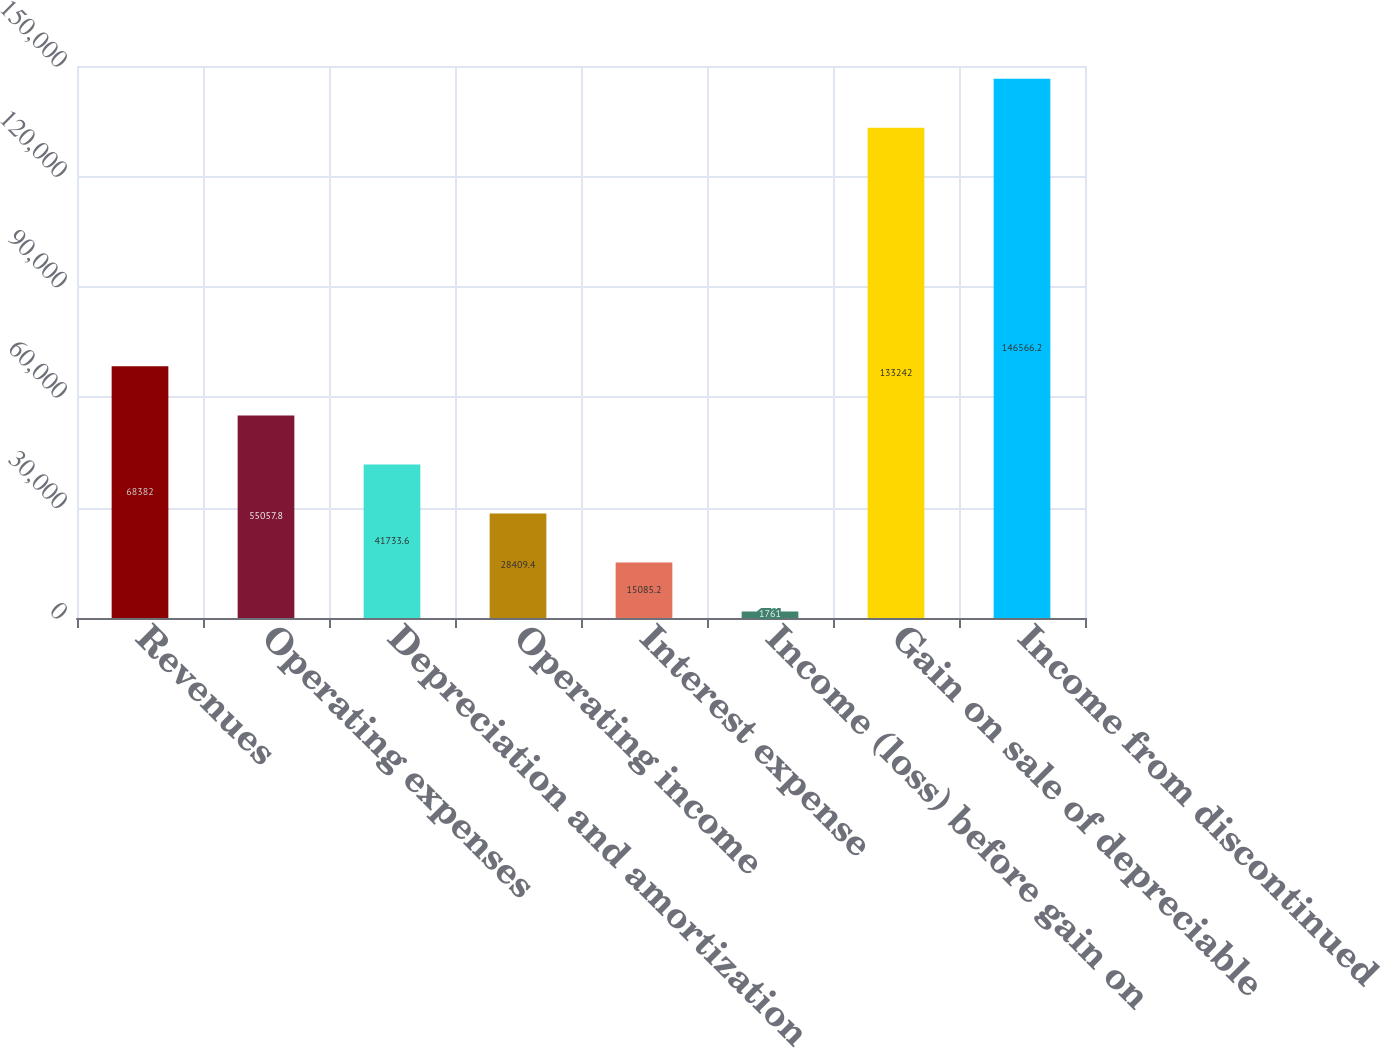<chart> <loc_0><loc_0><loc_500><loc_500><bar_chart><fcel>Revenues<fcel>Operating expenses<fcel>Depreciation and amortization<fcel>Operating income<fcel>Interest expense<fcel>Income (loss) before gain on<fcel>Gain on sale of depreciable<fcel>Income from discontinued<nl><fcel>68382<fcel>55057.8<fcel>41733.6<fcel>28409.4<fcel>15085.2<fcel>1761<fcel>133242<fcel>146566<nl></chart> 